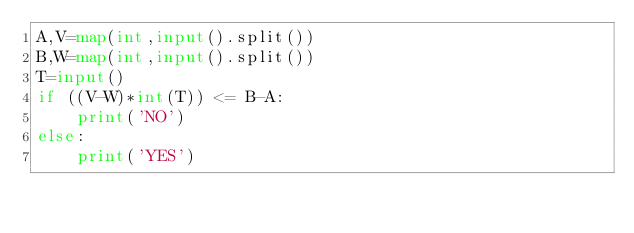<code> <loc_0><loc_0><loc_500><loc_500><_Python_>A,V=map(int,input().split())
B,W=map(int,input().split())
T=input()
if ((V-W)*int(T)) <= B-A:
    print('NO')
else:
    print('YES')
</code> 